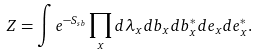Convert formula to latex. <formula><loc_0><loc_0><loc_500><loc_500>Z = \int e ^ { - S _ { s b } } \prod _ { x } d \lambda _ { x } d b _ { x } d b _ { x } ^ { * } d e _ { x } d e _ { x } ^ { * } .</formula> 